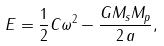Convert formula to latex. <formula><loc_0><loc_0><loc_500><loc_500>E = \frac { 1 } { 2 } C \omega ^ { 2 } - \frac { G M _ { s } M _ { p } } { 2 \, a } ,</formula> 